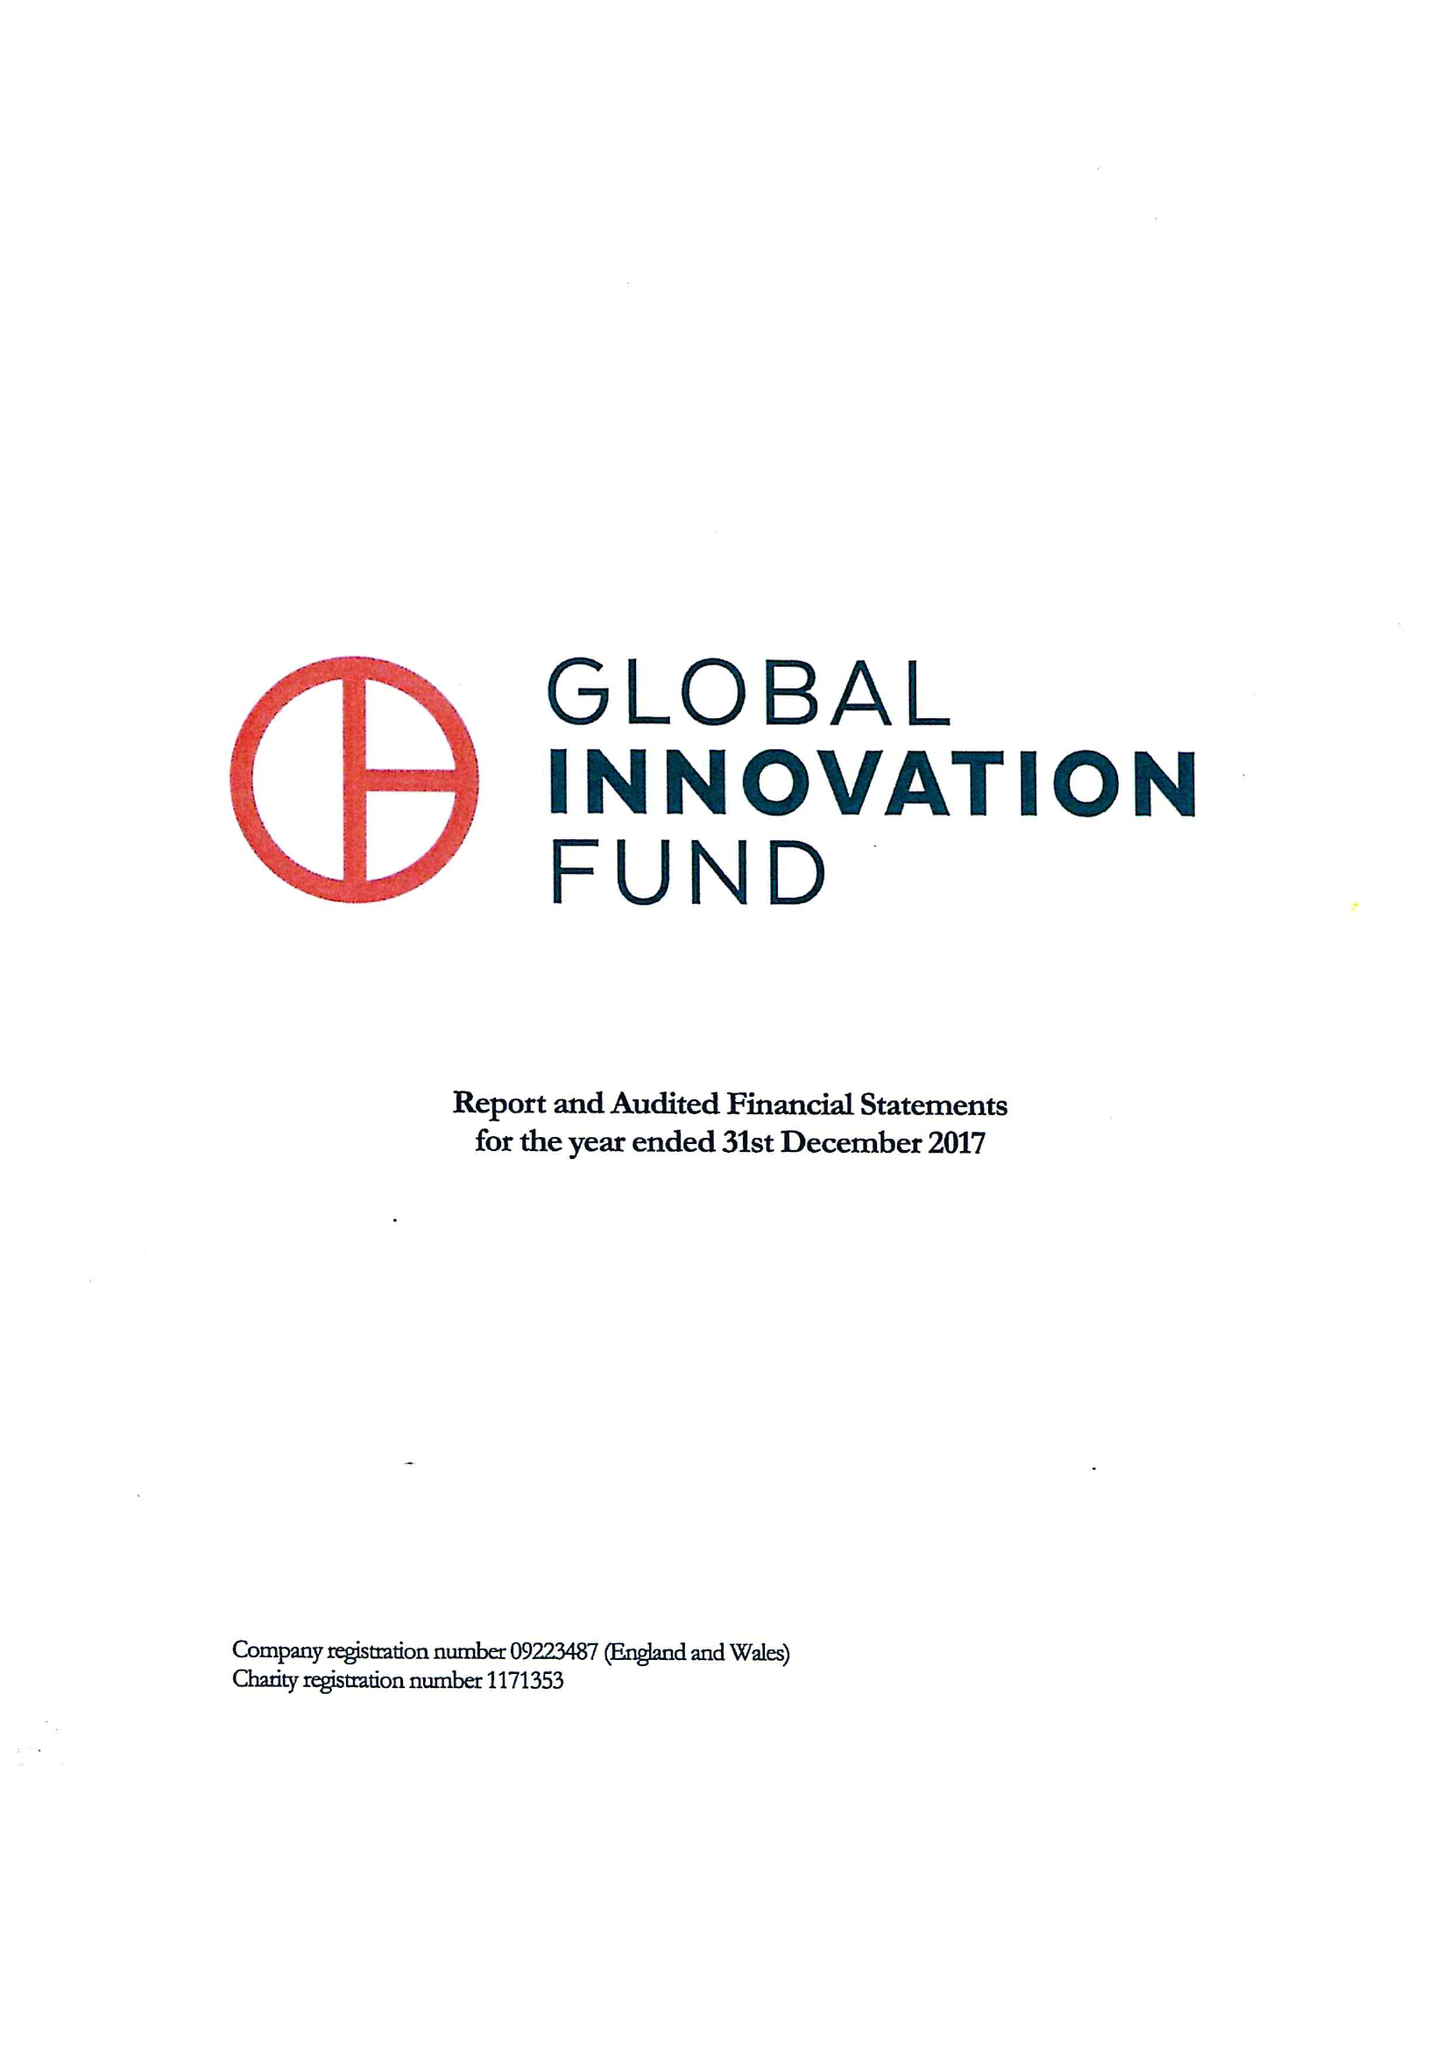What is the value for the spending_annually_in_british_pounds?
Answer the question using a single word or phrase. 12187000.00 